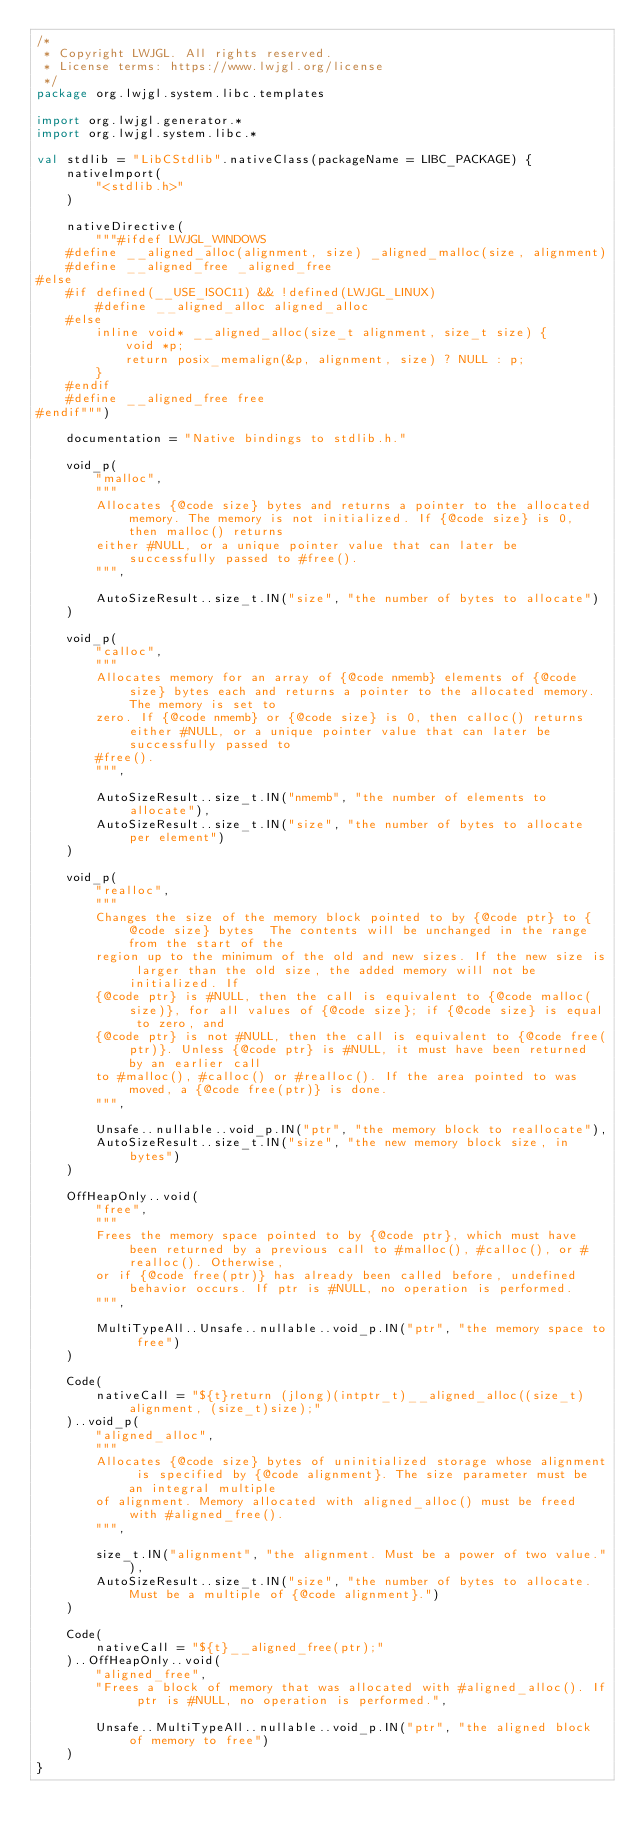<code> <loc_0><loc_0><loc_500><loc_500><_Kotlin_>/*
 * Copyright LWJGL. All rights reserved.
 * License terms: https://www.lwjgl.org/license
 */
package org.lwjgl.system.libc.templates

import org.lwjgl.generator.*
import org.lwjgl.system.libc.*

val stdlib = "LibCStdlib".nativeClass(packageName = LIBC_PACKAGE) {
    nativeImport(
        "<stdlib.h>"
    )

    nativeDirective(
        """#ifdef LWJGL_WINDOWS
    #define __aligned_alloc(alignment, size) _aligned_malloc(size, alignment)
    #define __aligned_free _aligned_free
#else
    #if defined(__USE_ISOC11) && !defined(LWJGL_LINUX)
        #define __aligned_alloc aligned_alloc
    #else
        inline void* __aligned_alloc(size_t alignment, size_t size) {
            void *p;
            return posix_memalign(&p, alignment, size) ? NULL : p;
        }
    #endif
    #define __aligned_free free
#endif""")

    documentation = "Native bindings to stdlib.h."

    void_p(
        "malloc",
        """
        Allocates {@code size} bytes and returns a pointer to the allocated memory. The memory is not initialized. If {@code size} is 0, then malloc() returns
        either #NULL, or a unique pointer value that can later be successfully passed to #free().
        """,

        AutoSizeResult..size_t.IN("size", "the number of bytes to allocate")
    )

    void_p(
        "calloc",
        """
        Allocates memory for an array of {@code nmemb} elements of {@code size} bytes each and returns a pointer to the allocated memory. The memory is set to
        zero. If {@code nmemb} or {@code size} is 0, then calloc() returns either #NULL, or a unique pointer value that can later be successfully passed to
        #free().
        """,

        AutoSizeResult..size_t.IN("nmemb", "the number of elements to allocate"),
        AutoSizeResult..size_t.IN("size", "the number of bytes to allocate per element")
    )

    void_p(
        "realloc",
        """
        Changes the size of the memory block pointed to by {@code ptr} to {@code size} bytes  The contents will be unchanged in the range from the start of the
        region up to the minimum of the old and new sizes. If the new size is larger than the old size, the added memory will not be initialized. If
        {@code ptr} is #NULL, then the call is equivalent to {@code malloc(size)}, for all values of {@code size}; if {@code size} is equal to zero, and
        {@code ptr} is not #NULL, then the call is equivalent to {@code free(ptr)}. Unless {@code ptr} is #NULL, it must have been returned by an earlier call
        to #malloc(), #calloc() or #realloc(). If the area pointed to was moved, a {@code free(ptr)} is done.
        """,

        Unsafe..nullable..void_p.IN("ptr", "the memory block to reallocate"),
        AutoSizeResult..size_t.IN("size", "the new memory block size, in bytes")
    )

    OffHeapOnly..void(
        "free",
        """
        Frees the memory space pointed to by {@code ptr}, which must have been returned by a previous call to #malloc(), #calloc(), or #realloc(). Otherwise,
        or if {@code free(ptr)} has already been called before, undefined behavior occurs. If ptr is #NULL, no operation is performed.
        """,

        MultiTypeAll..Unsafe..nullable..void_p.IN("ptr", "the memory space to free")
    )

    Code(
        nativeCall = "${t}return (jlong)(intptr_t)__aligned_alloc((size_t)alignment, (size_t)size);"
    )..void_p(
        "aligned_alloc",
        """
        Allocates {@code size} bytes of uninitialized storage whose alignment is specified by {@code alignment}. The size parameter must be an integral multiple
        of alignment. Memory allocated with aligned_alloc() must be freed with #aligned_free().
        """,

        size_t.IN("alignment", "the alignment. Must be a power of two value."),
        AutoSizeResult..size_t.IN("size", "the number of bytes to allocate. Must be a multiple of {@code alignment}.")
    )

    Code(
        nativeCall = "${t}__aligned_free(ptr);"
    )..OffHeapOnly..void(
        "aligned_free",
        "Frees a block of memory that was allocated with #aligned_alloc(). If ptr is #NULL, no operation is performed.",

        Unsafe..MultiTypeAll..nullable..void_p.IN("ptr", "the aligned block of memory to free")
    )
}</code> 